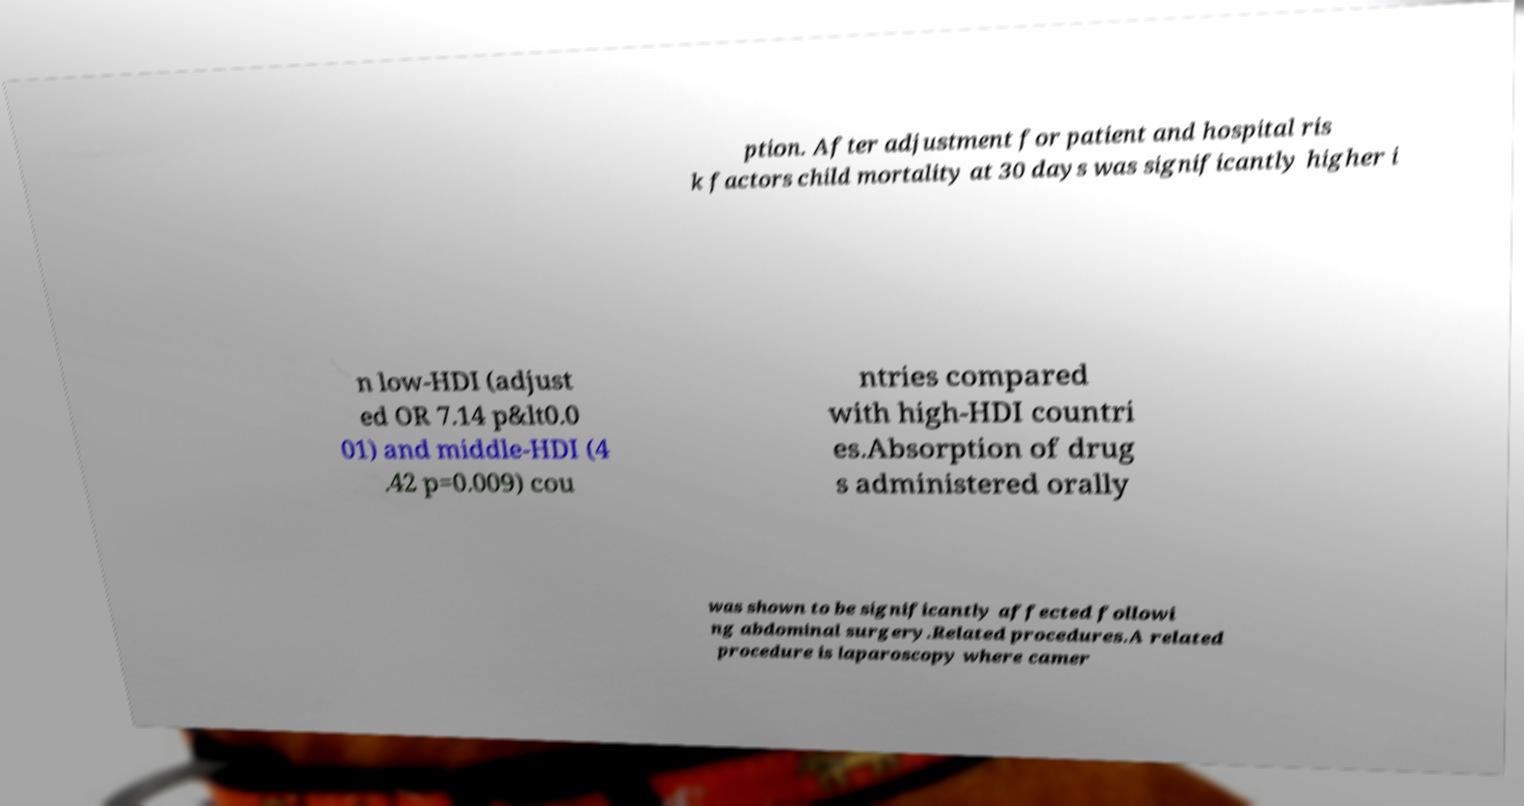Could you extract and type out the text from this image? ption. After adjustment for patient and hospital ris k factors child mortality at 30 days was significantly higher i n low-HDI (adjust ed OR 7.14 p&lt0.0 01) and middle-HDI (4 .42 p=0.009) cou ntries compared with high-HDI countri es.Absorption of drug s administered orally was shown to be significantly affected followi ng abdominal surgery.Related procedures.A related procedure is laparoscopy where camer 